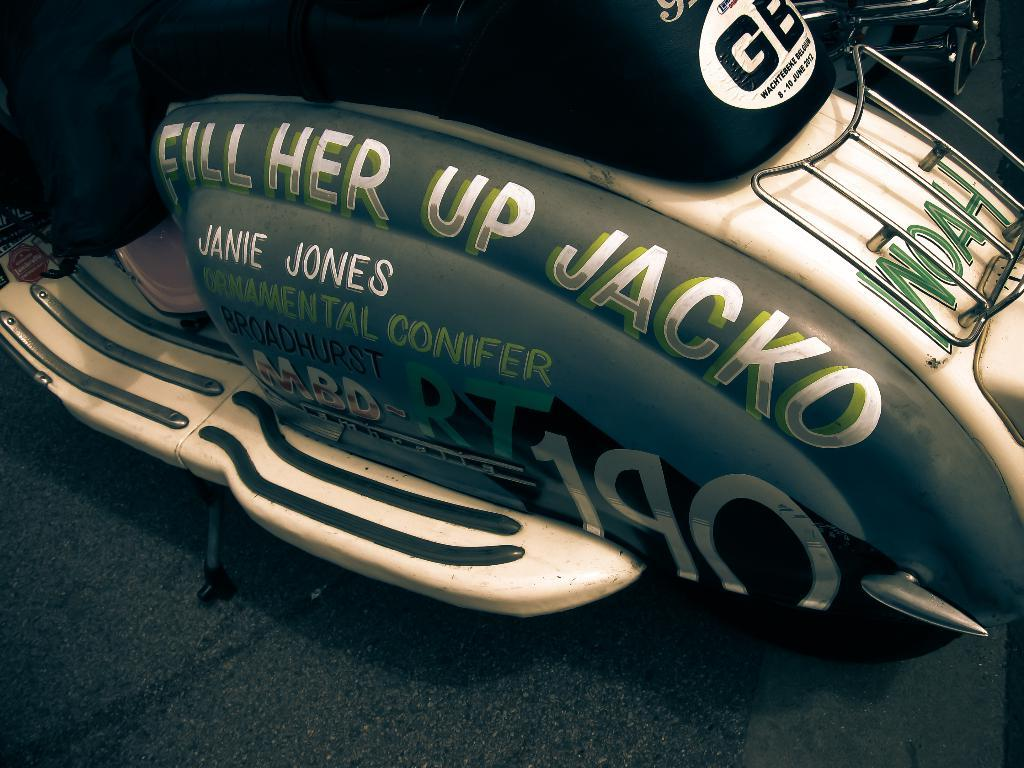What can be observed about the image's appearance? The image appears to be edited. What is the main subject in the middle of the image? There is a vehicle in the middle of the image. What type of vehicle is it? The vehicle resembles a scooter. Is there any text or writing on the scooter? Yes, there is text or writing on the scooter. Who is the owner of the scooter in the image? The image does not provide information about the owner of the scooter. Can you see a monkey riding the scooter in the image? There is no monkey present in the image, and the scooter is not being ridden by anyone. 